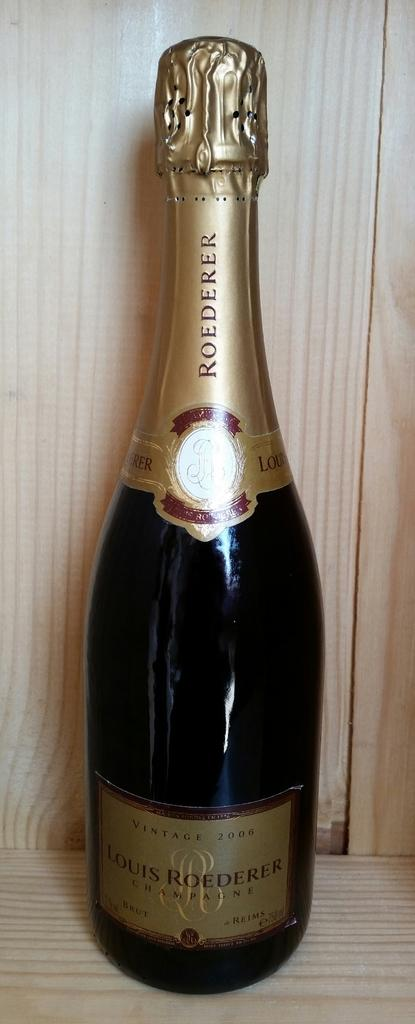Provide a one-sentence caption for the provided image. Unopened Roederer wine bottle sitting on a wooden platform. 